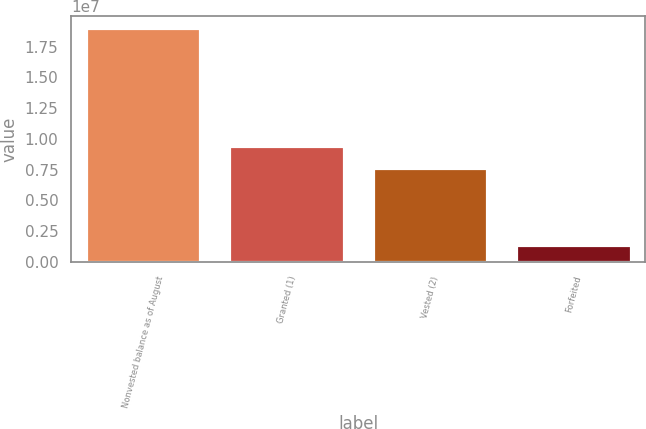Convert chart. <chart><loc_0><loc_0><loc_500><loc_500><bar_chart><fcel>Nonvested balance as of August<fcel>Granted (1)<fcel>Vested (2)<fcel>Forfeited<nl><fcel>1.90021e+07<fcel>9.39355e+06<fcel>7.62512e+06<fcel>1.39432e+06<nl></chart> 